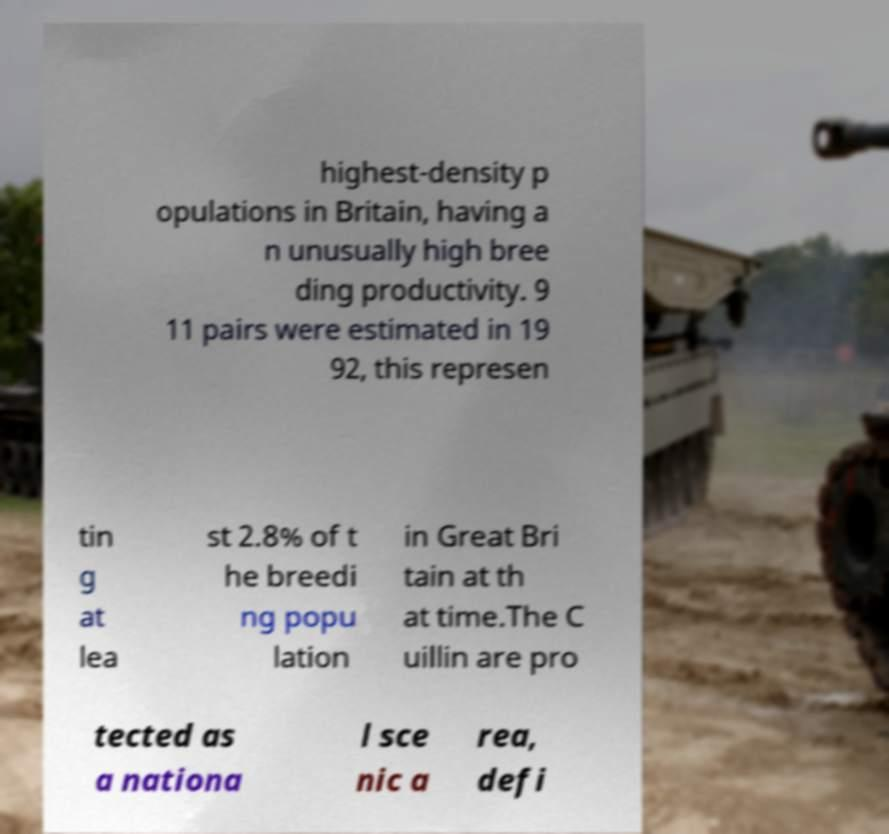Can you accurately transcribe the text from the provided image for me? highest-density p opulations in Britain, having a n unusually high bree ding productivity. 9 11 pairs were estimated in 19 92, this represen tin g at lea st 2.8% of t he breedi ng popu lation in Great Bri tain at th at time.The C uillin are pro tected as a nationa l sce nic a rea, defi 